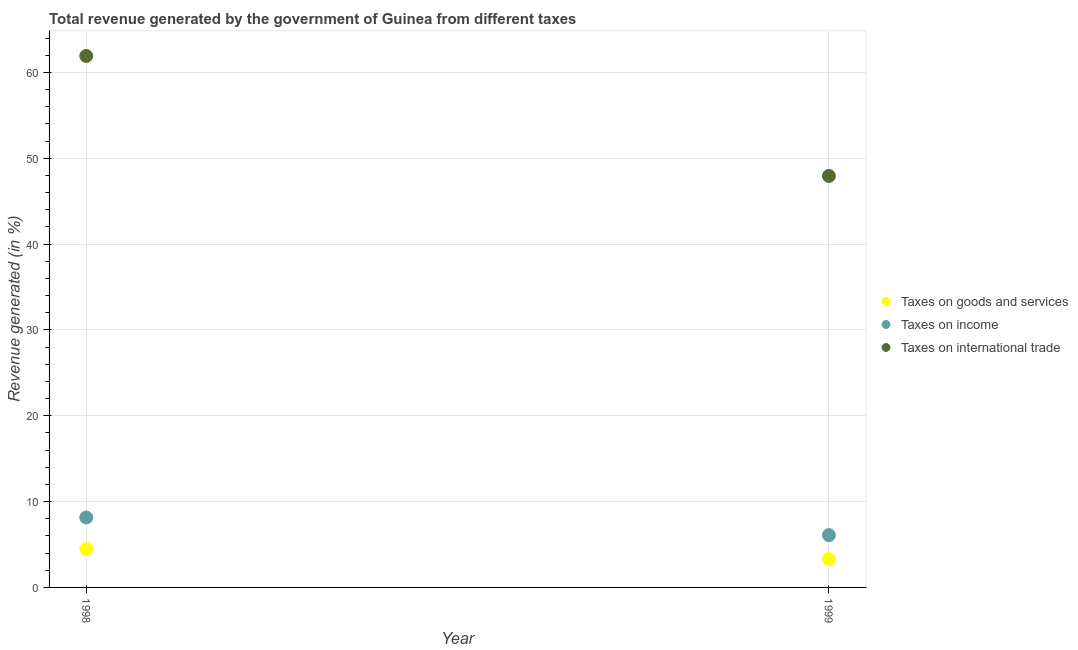Is the number of dotlines equal to the number of legend labels?
Provide a succinct answer. Yes. What is the percentage of revenue generated by tax on international trade in 1998?
Offer a very short reply. 61.91. Across all years, what is the maximum percentage of revenue generated by tax on international trade?
Make the answer very short. 61.91. Across all years, what is the minimum percentage of revenue generated by taxes on income?
Your answer should be compact. 6.09. What is the total percentage of revenue generated by tax on international trade in the graph?
Your answer should be compact. 109.84. What is the difference between the percentage of revenue generated by taxes on goods and services in 1998 and that in 1999?
Your answer should be very brief. 1.2. What is the difference between the percentage of revenue generated by tax on international trade in 1999 and the percentage of revenue generated by taxes on income in 1998?
Your answer should be very brief. 39.78. What is the average percentage of revenue generated by tax on international trade per year?
Make the answer very short. 54.92. In the year 1999, what is the difference between the percentage of revenue generated by tax on international trade and percentage of revenue generated by taxes on goods and services?
Provide a short and direct response. 44.63. In how many years, is the percentage of revenue generated by tax on international trade greater than 16 %?
Your response must be concise. 2. What is the ratio of the percentage of revenue generated by taxes on goods and services in 1998 to that in 1999?
Your answer should be compact. 1.36. In how many years, is the percentage of revenue generated by taxes on income greater than the average percentage of revenue generated by taxes on income taken over all years?
Provide a succinct answer. 1. Does the percentage of revenue generated by taxes on income monotonically increase over the years?
Provide a succinct answer. No. Is the percentage of revenue generated by taxes on goods and services strictly less than the percentage of revenue generated by tax on international trade over the years?
Your answer should be compact. Yes. How many dotlines are there?
Provide a short and direct response. 3. How many years are there in the graph?
Offer a terse response. 2. What is the difference between two consecutive major ticks on the Y-axis?
Your answer should be very brief. 10. Are the values on the major ticks of Y-axis written in scientific E-notation?
Give a very brief answer. No. Does the graph contain any zero values?
Keep it short and to the point. No. Where does the legend appear in the graph?
Your answer should be very brief. Center right. What is the title of the graph?
Ensure brevity in your answer.  Total revenue generated by the government of Guinea from different taxes. What is the label or title of the Y-axis?
Make the answer very short. Revenue generated (in %). What is the Revenue generated (in %) in Taxes on goods and services in 1998?
Offer a very short reply. 4.5. What is the Revenue generated (in %) of Taxes on income in 1998?
Your answer should be compact. 8.15. What is the Revenue generated (in %) in Taxes on international trade in 1998?
Give a very brief answer. 61.91. What is the Revenue generated (in %) of Taxes on goods and services in 1999?
Your answer should be compact. 3.3. What is the Revenue generated (in %) in Taxes on income in 1999?
Your answer should be compact. 6.09. What is the Revenue generated (in %) in Taxes on international trade in 1999?
Make the answer very short. 47.93. Across all years, what is the maximum Revenue generated (in %) in Taxes on goods and services?
Your answer should be very brief. 4.5. Across all years, what is the maximum Revenue generated (in %) in Taxes on income?
Provide a short and direct response. 8.15. Across all years, what is the maximum Revenue generated (in %) in Taxes on international trade?
Your response must be concise. 61.91. Across all years, what is the minimum Revenue generated (in %) of Taxes on goods and services?
Make the answer very short. 3.3. Across all years, what is the minimum Revenue generated (in %) in Taxes on income?
Offer a terse response. 6.09. Across all years, what is the minimum Revenue generated (in %) of Taxes on international trade?
Your response must be concise. 47.93. What is the total Revenue generated (in %) of Taxes on goods and services in the graph?
Provide a short and direct response. 7.79. What is the total Revenue generated (in %) of Taxes on income in the graph?
Your answer should be very brief. 14.24. What is the total Revenue generated (in %) in Taxes on international trade in the graph?
Your answer should be compact. 109.84. What is the difference between the Revenue generated (in %) in Taxes on goods and services in 1998 and that in 1999?
Offer a terse response. 1.2. What is the difference between the Revenue generated (in %) in Taxes on income in 1998 and that in 1999?
Your answer should be compact. 2.05. What is the difference between the Revenue generated (in %) in Taxes on international trade in 1998 and that in 1999?
Your response must be concise. 13.98. What is the difference between the Revenue generated (in %) in Taxes on goods and services in 1998 and the Revenue generated (in %) in Taxes on income in 1999?
Your answer should be compact. -1.6. What is the difference between the Revenue generated (in %) of Taxes on goods and services in 1998 and the Revenue generated (in %) of Taxes on international trade in 1999?
Your response must be concise. -43.44. What is the difference between the Revenue generated (in %) in Taxes on income in 1998 and the Revenue generated (in %) in Taxes on international trade in 1999?
Keep it short and to the point. -39.78. What is the average Revenue generated (in %) of Taxes on goods and services per year?
Your answer should be very brief. 3.9. What is the average Revenue generated (in %) in Taxes on income per year?
Your answer should be very brief. 7.12. What is the average Revenue generated (in %) of Taxes on international trade per year?
Provide a succinct answer. 54.92. In the year 1998, what is the difference between the Revenue generated (in %) in Taxes on goods and services and Revenue generated (in %) in Taxes on income?
Give a very brief answer. -3.65. In the year 1998, what is the difference between the Revenue generated (in %) in Taxes on goods and services and Revenue generated (in %) in Taxes on international trade?
Provide a short and direct response. -57.41. In the year 1998, what is the difference between the Revenue generated (in %) in Taxes on income and Revenue generated (in %) in Taxes on international trade?
Give a very brief answer. -53.76. In the year 1999, what is the difference between the Revenue generated (in %) of Taxes on goods and services and Revenue generated (in %) of Taxes on income?
Provide a succinct answer. -2.8. In the year 1999, what is the difference between the Revenue generated (in %) in Taxes on goods and services and Revenue generated (in %) in Taxes on international trade?
Ensure brevity in your answer.  -44.63. In the year 1999, what is the difference between the Revenue generated (in %) of Taxes on income and Revenue generated (in %) of Taxes on international trade?
Ensure brevity in your answer.  -41.84. What is the ratio of the Revenue generated (in %) of Taxes on goods and services in 1998 to that in 1999?
Ensure brevity in your answer.  1.36. What is the ratio of the Revenue generated (in %) of Taxes on income in 1998 to that in 1999?
Your answer should be very brief. 1.34. What is the ratio of the Revenue generated (in %) of Taxes on international trade in 1998 to that in 1999?
Keep it short and to the point. 1.29. What is the difference between the highest and the second highest Revenue generated (in %) of Taxes on goods and services?
Your answer should be compact. 1.2. What is the difference between the highest and the second highest Revenue generated (in %) in Taxes on income?
Provide a short and direct response. 2.05. What is the difference between the highest and the second highest Revenue generated (in %) of Taxes on international trade?
Your answer should be compact. 13.98. What is the difference between the highest and the lowest Revenue generated (in %) in Taxes on goods and services?
Provide a succinct answer. 1.2. What is the difference between the highest and the lowest Revenue generated (in %) in Taxes on income?
Your answer should be very brief. 2.05. What is the difference between the highest and the lowest Revenue generated (in %) in Taxes on international trade?
Provide a succinct answer. 13.98. 